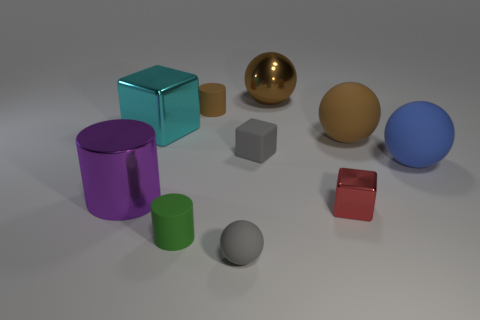Are there fewer blocks that are on the right side of the big block than large rubber spheres in front of the gray sphere?
Make the answer very short. No. There is another shiny thing that is the same shape as the large cyan metal object; what is its color?
Your response must be concise. Red. Is the size of the gray matte object in front of the red block the same as the tiny matte cube?
Your answer should be compact. Yes. Is the number of green cylinders that are right of the small green matte cylinder less than the number of large matte blocks?
Your answer should be very brief. No. Are there any other things that are the same size as the purple metal object?
Your answer should be compact. Yes. There is a sphere that is on the left side of the small gray matte cube that is behind the tiny red metallic object; what size is it?
Your response must be concise. Small. Is there any other thing that is the same shape as the large purple metallic object?
Your answer should be very brief. Yes. Is the number of big metal blocks less than the number of big objects?
Give a very brief answer. Yes. There is a cylinder that is both right of the purple metal cylinder and behind the green object; what is its material?
Provide a succinct answer. Rubber. Are there any objects on the left side of the metallic block on the left side of the shiny ball?
Provide a succinct answer. Yes. 